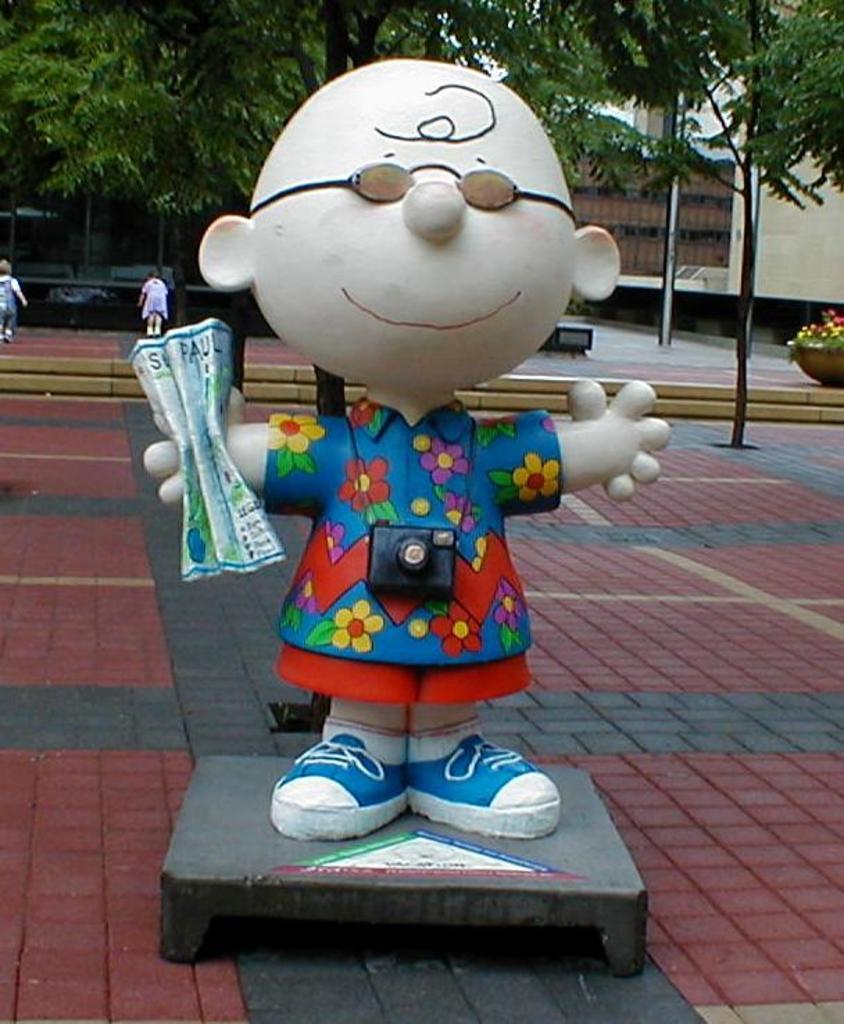Please provide a concise description of this image. In the center of the image there is a depiction of a person. In the background of the image there are trees,buildings. At the bottom of the image there is pavement. 